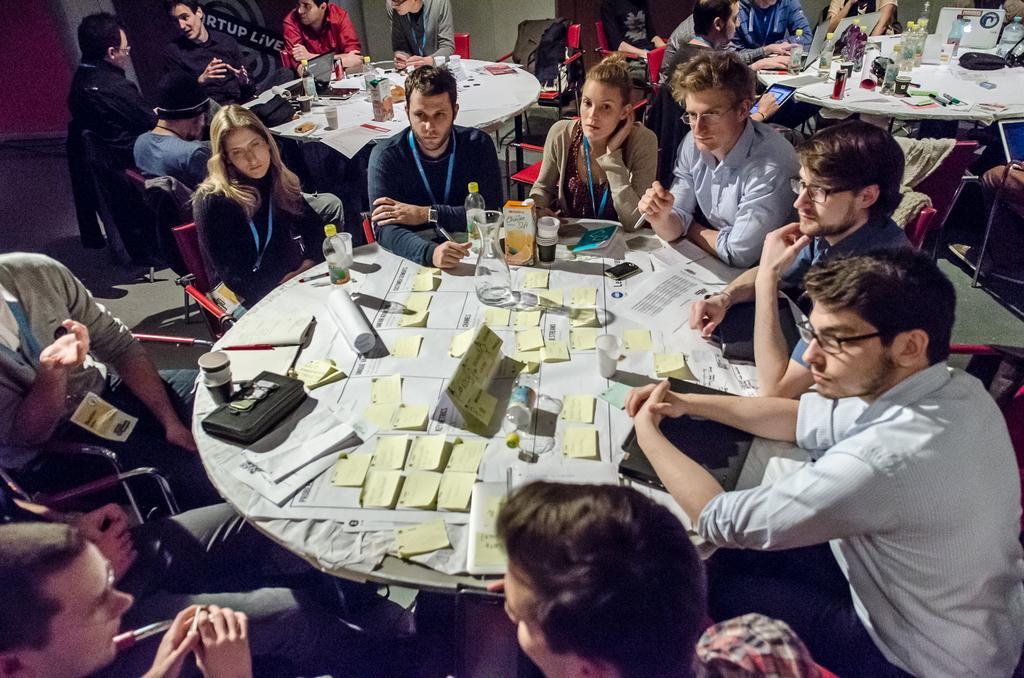How would you summarize this image in a sentence or two? In this picture we can see a group of people sitting on chair and in front of them on table we have papers, purse, glasses, bottle, jar, box, mobile, book and in background we can see some more persons and tables, wall, jackets on chair. 